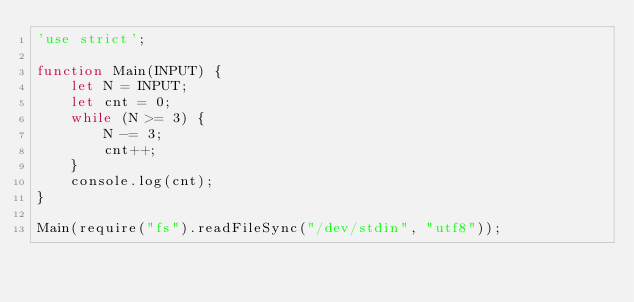Convert code to text. <code><loc_0><loc_0><loc_500><loc_500><_JavaScript_>'use strict';

function Main(INPUT) {
    let N = INPUT;
    let cnt = 0;
    while (N >= 3) {
        N -= 3;
        cnt++;
    }
    console.log(cnt);
}

Main(require("fs").readFileSync("/dev/stdin", "utf8"));
</code> 